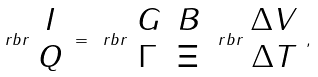<formula> <loc_0><loc_0><loc_500><loc_500>\ r b r { \begin{array} { c } I \\ Q \end{array} } = \ r b r { \begin{array} { c c } G & B \\ \Gamma & \Xi \end{array} } \ r b r { \begin{array} { c } \Delta V \\ \Delta T \end{array} } ,</formula> 